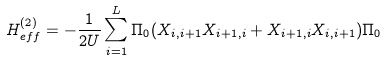<formula> <loc_0><loc_0><loc_500><loc_500>H _ { e f f } ^ { ( 2 ) } = - \frac { 1 } { 2 U } \sum _ { i = 1 } ^ { L } \Pi _ { 0 } ( X _ { i , i + 1 } X _ { i + 1 , i } + X _ { i + 1 , i } X _ { i , i + 1 } ) \Pi _ { 0 }</formula> 